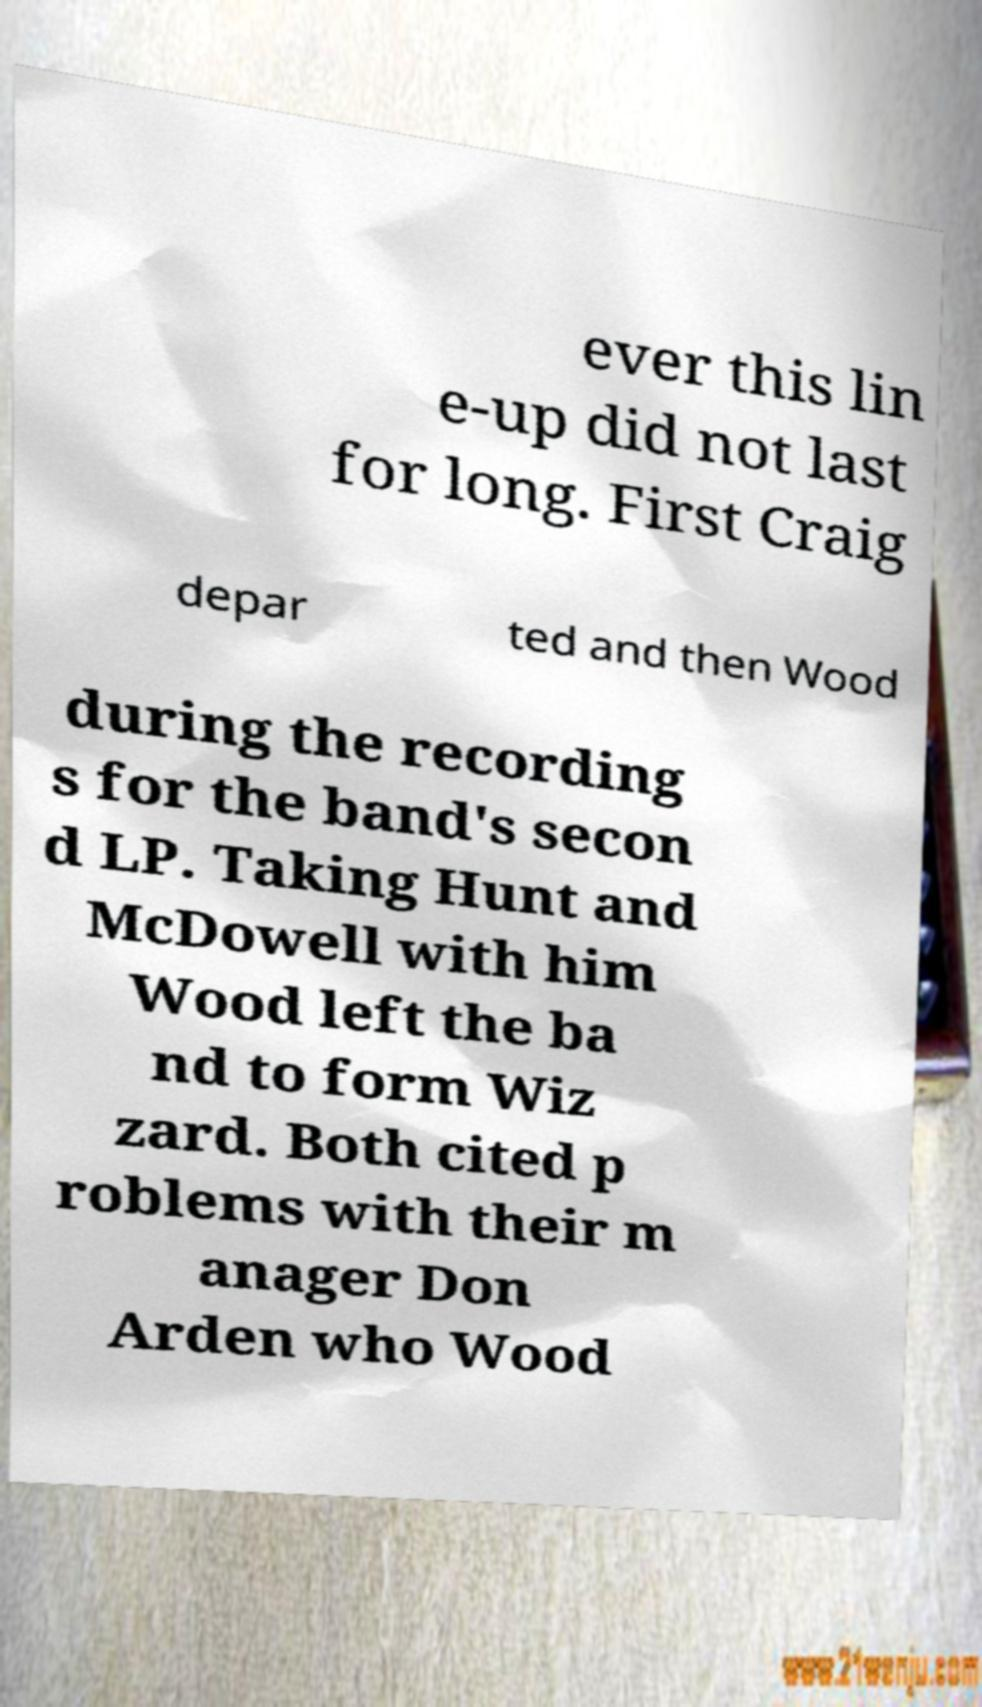I need the written content from this picture converted into text. Can you do that? ever this lin e-up did not last for long. First Craig depar ted and then Wood during the recording s for the band's secon d LP. Taking Hunt and McDowell with him Wood left the ba nd to form Wiz zard. Both cited p roblems with their m anager Don Arden who Wood 